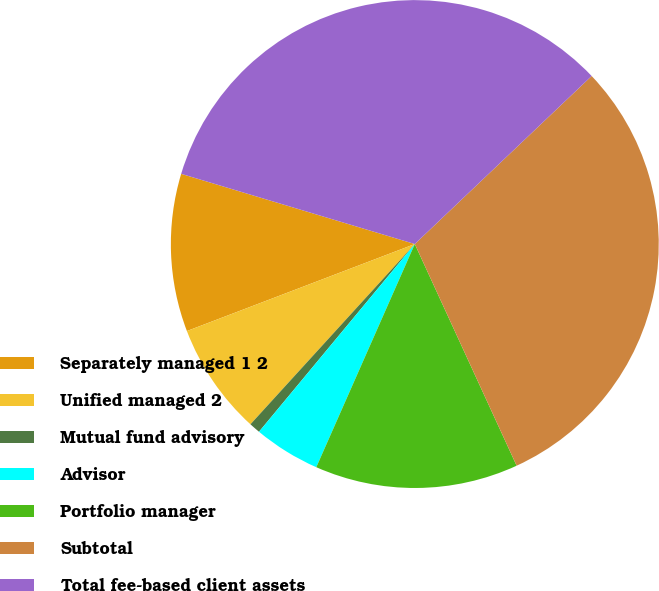Convert chart. <chart><loc_0><loc_0><loc_500><loc_500><pie_chart><fcel>Separately managed 1 2<fcel>Unified managed 2<fcel>Mutual fund advisory<fcel>Advisor<fcel>Portfolio manager<fcel>Subtotal<fcel>Total fee-based client assets<nl><fcel>10.45%<fcel>7.43%<fcel>0.74%<fcel>4.41%<fcel>13.47%<fcel>30.24%<fcel>33.26%<nl></chart> 